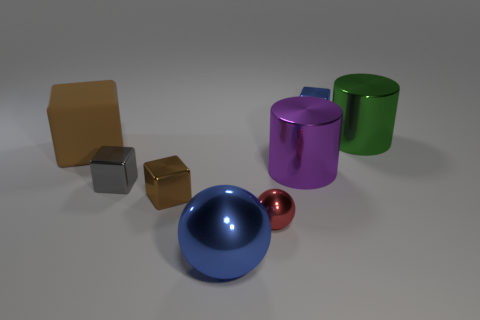Is there any other thing that is the same size as the gray thing?
Offer a terse response. Yes. There is a small cube behind the purple metal cylinder; are there any small metallic objects that are behind it?
Offer a very short reply. No. There is a blue thing that is behind the red ball; is its size the same as the large brown cube?
Make the answer very short. No. The gray cube is what size?
Provide a short and direct response. Small. Is there a big matte ball of the same color as the rubber cube?
Your answer should be compact. No. What number of small things are either green metal cylinders or blue objects?
Your response must be concise. 1. There is a cube that is both right of the small gray cube and in front of the large brown object; what is its size?
Make the answer very short. Small. There is a tiny ball; what number of tiny blue objects are behind it?
Provide a succinct answer. 1. There is a thing that is both behind the big purple cylinder and on the left side of the red shiny object; what is its shape?
Your response must be concise. Cube. There is a object that is the same color as the matte cube; what is its material?
Offer a terse response. Metal. 